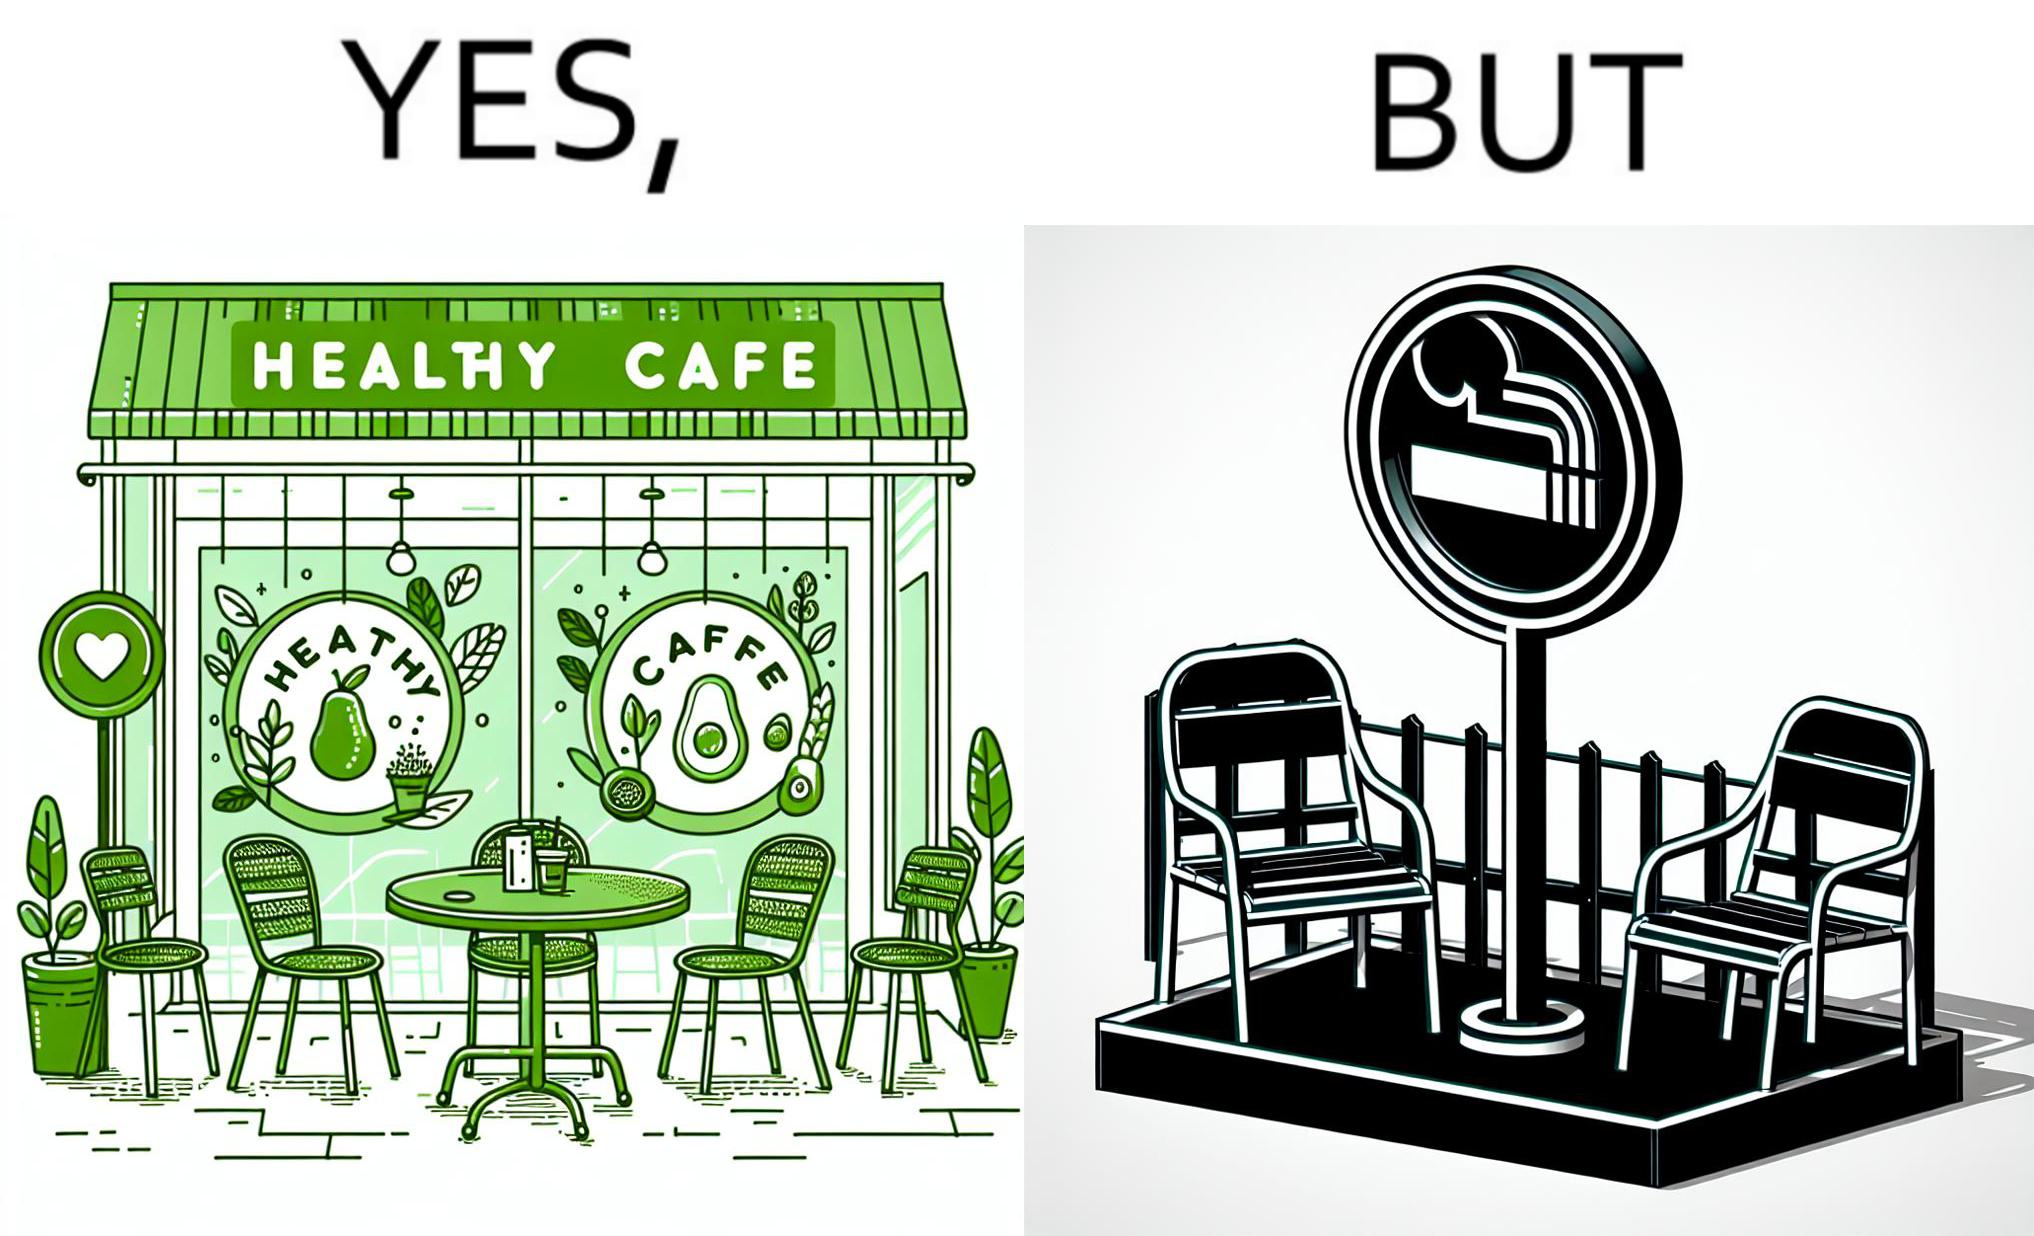Explain the humor or irony in this image. This image is funny because an eatery that calls itself the "healthy" cafe also has a smoking area, which is not very "healthy". If it really was a healthy cafe, it would not have a smoking area as smoking is injurious to health. Satire on the behavior of humans - both those that operate this cafe who made the decision of allowing smoking and creating a designated smoking area, and those that visit this healthy cafe to become "healthy", but then also indulge in very unhealthy habits simultaneously. 